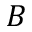Convert formula to latex. <formula><loc_0><loc_0><loc_500><loc_500>B</formula> 